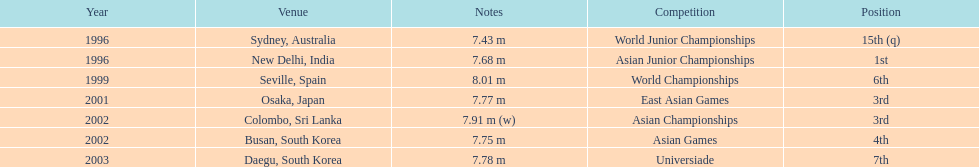What is the discrepancy in the occurrences of reaching first and third positions? 1. 